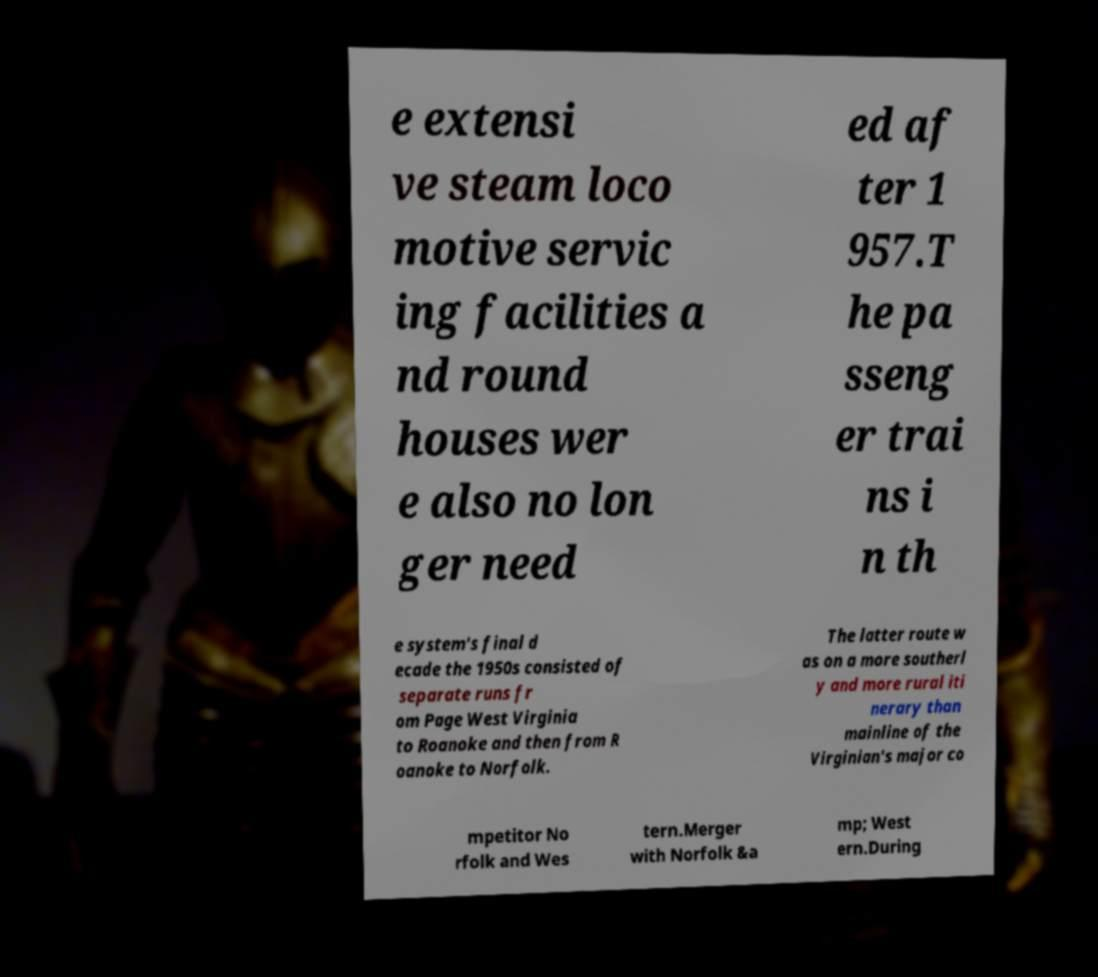Can you read and provide the text displayed in the image?This photo seems to have some interesting text. Can you extract and type it out for me? e extensi ve steam loco motive servic ing facilities a nd round houses wer e also no lon ger need ed af ter 1 957.T he pa sseng er trai ns i n th e system's final d ecade the 1950s consisted of separate runs fr om Page West Virginia to Roanoke and then from R oanoke to Norfolk. The latter route w as on a more southerl y and more rural iti nerary than mainline of the Virginian's major co mpetitor No rfolk and Wes tern.Merger with Norfolk &a mp; West ern.During 